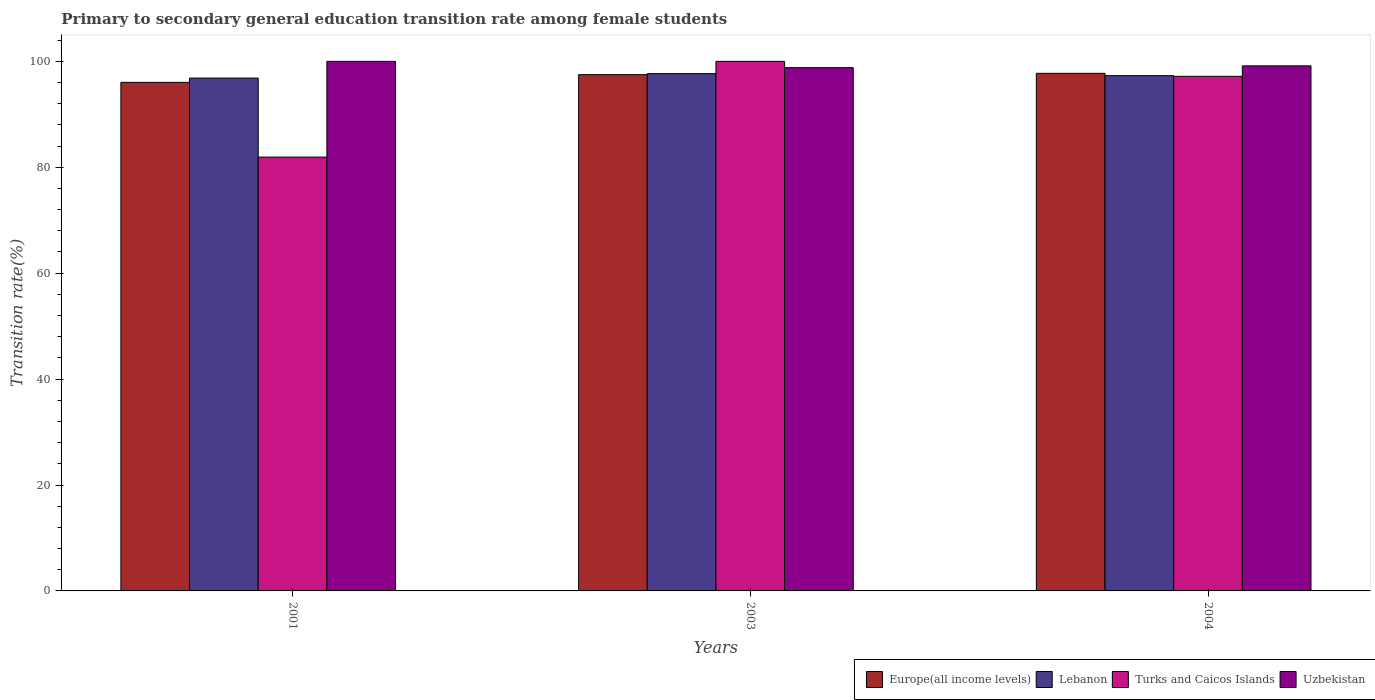How many groups of bars are there?
Ensure brevity in your answer.  3. Are the number of bars per tick equal to the number of legend labels?
Ensure brevity in your answer.  Yes. What is the transition rate in Europe(all income levels) in 2003?
Your answer should be compact. 97.49. Across all years, what is the maximum transition rate in Lebanon?
Provide a succinct answer. 97.69. Across all years, what is the minimum transition rate in Lebanon?
Ensure brevity in your answer.  96.84. In which year was the transition rate in Turks and Caicos Islands minimum?
Make the answer very short. 2001. What is the total transition rate in Europe(all income levels) in the graph?
Your response must be concise. 291.26. What is the difference between the transition rate in Turks and Caicos Islands in 2001 and that in 2004?
Provide a short and direct response. -15.25. What is the difference between the transition rate in Lebanon in 2003 and the transition rate in Europe(all income levels) in 2001?
Ensure brevity in your answer.  1.65. What is the average transition rate in Turks and Caicos Islands per year?
Your answer should be very brief. 93.03. In the year 2003, what is the difference between the transition rate in Uzbekistan and transition rate in Turks and Caicos Islands?
Offer a terse response. -1.19. In how many years, is the transition rate in Uzbekistan greater than 100 %?
Your response must be concise. 0. What is the ratio of the transition rate in Europe(all income levels) in 2001 to that in 2003?
Your answer should be compact. 0.99. Is the transition rate in Turks and Caicos Islands in 2001 less than that in 2003?
Keep it short and to the point. Yes. Is the difference between the transition rate in Uzbekistan in 2003 and 2004 greater than the difference between the transition rate in Turks and Caicos Islands in 2003 and 2004?
Your response must be concise. No. What is the difference between the highest and the second highest transition rate in Europe(all income levels)?
Offer a terse response. 0.25. What is the difference between the highest and the lowest transition rate in Europe(all income levels)?
Ensure brevity in your answer.  1.7. In how many years, is the transition rate in Turks and Caicos Islands greater than the average transition rate in Turks and Caicos Islands taken over all years?
Provide a short and direct response. 2. Is it the case that in every year, the sum of the transition rate in Uzbekistan and transition rate in Europe(all income levels) is greater than the sum of transition rate in Turks and Caicos Islands and transition rate in Lebanon?
Offer a terse response. No. What does the 1st bar from the left in 2003 represents?
Offer a terse response. Europe(all income levels). What does the 4th bar from the right in 2003 represents?
Offer a very short reply. Europe(all income levels). How many years are there in the graph?
Offer a very short reply. 3. What is the difference between two consecutive major ticks on the Y-axis?
Your answer should be compact. 20. Are the values on the major ticks of Y-axis written in scientific E-notation?
Make the answer very short. No. Where does the legend appear in the graph?
Give a very brief answer. Bottom right. How many legend labels are there?
Your answer should be compact. 4. What is the title of the graph?
Your answer should be compact. Primary to secondary general education transition rate among female students. What is the label or title of the X-axis?
Make the answer very short. Years. What is the label or title of the Y-axis?
Your answer should be compact. Transition rate(%). What is the Transition rate(%) in Europe(all income levels) in 2001?
Give a very brief answer. 96.03. What is the Transition rate(%) of Lebanon in 2001?
Offer a very short reply. 96.84. What is the Transition rate(%) of Turks and Caicos Islands in 2001?
Provide a succinct answer. 81.92. What is the Transition rate(%) in Uzbekistan in 2001?
Provide a short and direct response. 100. What is the Transition rate(%) in Europe(all income levels) in 2003?
Provide a succinct answer. 97.49. What is the Transition rate(%) in Lebanon in 2003?
Make the answer very short. 97.69. What is the Transition rate(%) in Uzbekistan in 2003?
Provide a succinct answer. 98.81. What is the Transition rate(%) in Europe(all income levels) in 2004?
Keep it short and to the point. 97.74. What is the Transition rate(%) of Lebanon in 2004?
Provide a succinct answer. 97.3. What is the Transition rate(%) in Turks and Caicos Islands in 2004?
Ensure brevity in your answer.  97.18. What is the Transition rate(%) in Uzbekistan in 2004?
Ensure brevity in your answer.  99.15. Across all years, what is the maximum Transition rate(%) of Europe(all income levels)?
Offer a terse response. 97.74. Across all years, what is the maximum Transition rate(%) in Lebanon?
Offer a terse response. 97.69. Across all years, what is the maximum Transition rate(%) of Turks and Caicos Islands?
Give a very brief answer. 100. Across all years, what is the minimum Transition rate(%) in Europe(all income levels)?
Offer a very short reply. 96.03. Across all years, what is the minimum Transition rate(%) of Lebanon?
Your response must be concise. 96.84. Across all years, what is the minimum Transition rate(%) in Turks and Caicos Islands?
Your answer should be compact. 81.92. Across all years, what is the minimum Transition rate(%) of Uzbekistan?
Your answer should be very brief. 98.81. What is the total Transition rate(%) of Europe(all income levels) in the graph?
Give a very brief answer. 291.26. What is the total Transition rate(%) of Lebanon in the graph?
Provide a short and direct response. 291.83. What is the total Transition rate(%) in Turks and Caicos Islands in the graph?
Your answer should be compact. 279.1. What is the total Transition rate(%) in Uzbekistan in the graph?
Offer a terse response. 297.96. What is the difference between the Transition rate(%) of Europe(all income levels) in 2001 and that in 2003?
Your answer should be very brief. -1.45. What is the difference between the Transition rate(%) of Lebanon in 2001 and that in 2003?
Offer a very short reply. -0.84. What is the difference between the Transition rate(%) of Turks and Caicos Islands in 2001 and that in 2003?
Give a very brief answer. -18.08. What is the difference between the Transition rate(%) of Uzbekistan in 2001 and that in 2003?
Your answer should be compact. 1.19. What is the difference between the Transition rate(%) in Europe(all income levels) in 2001 and that in 2004?
Offer a very short reply. -1.7. What is the difference between the Transition rate(%) in Lebanon in 2001 and that in 2004?
Give a very brief answer. -0.46. What is the difference between the Transition rate(%) in Turks and Caicos Islands in 2001 and that in 2004?
Give a very brief answer. -15.25. What is the difference between the Transition rate(%) of Uzbekistan in 2001 and that in 2004?
Offer a very short reply. 0.85. What is the difference between the Transition rate(%) of Europe(all income levels) in 2003 and that in 2004?
Provide a short and direct response. -0.25. What is the difference between the Transition rate(%) of Lebanon in 2003 and that in 2004?
Offer a very short reply. 0.39. What is the difference between the Transition rate(%) of Turks and Caicos Islands in 2003 and that in 2004?
Your answer should be compact. 2.82. What is the difference between the Transition rate(%) in Uzbekistan in 2003 and that in 2004?
Ensure brevity in your answer.  -0.34. What is the difference between the Transition rate(%) in Europe(all income levels) in 2001 and the Transition rate(%) in Lebanon in 2003?
Make the answer very short. -1.65. What is the difference between the Transition rate(%) in Europe(all income levels) in 2001 and the Transition rate(%) in Turks and Caicos Islands in 2003?
Your response must be concise. -3.97. What is the difference between the Transition rate(%) of Europe(all income levels) in 2001 and the Transition rate(%) of Uzbekistan in 2003?
Offer a terse response. -2.77. What is the difference between the Transition rate(%) in Lebanon in 2001 and the Transition rate(%) in Turks and Caicos Islands in 2003?
Provide a succinct answer. -3.16. What is the difference between the Transition rate(%) in Lebanon in 2001 and the Transition rate(%) in Uzbekistan in 2003?
Offer a very short reply. -1.96. What is the difference between the Transition rate(%) of Turks and Caicos Islands in 2001 and the Transition rate(%) of Uzbekistan in 2003?
Provide a succinct answer. -16.89. What is the difference between the Transition rate(%) in Europe(all income levels) in 2001 and the Transition rate(%) in Lebanon in 2004?
Your answer should be compact. -1.27. What is the difference between the Transition rate(%) in Europe(all income levels) in 2001 and the Transition rate(%) in Turks and Caicos Islands in 2004?
Provide a succinct answer. -1.14. What is the difference between the Transition rate(%) of Europe(all income levels) in 2001 and the Transition rate(%) of Uzbekistan in 2004?
Your answer should be very brief. -3.12. What is the difference between the Transition rate(%) of Lebanon in 2001 and the Transition rate(%) of Turks and Caicos Islands in 2004?
Your answer should be very brief. -0.33. What is the difference between the Transition rate(%) in Lebanon in 2001 and the Transition rate(%) in Uzbekistan in 2004?
Keep it short and to the point. -2.31. What is the difference between the Transition rate(%) of Turks and Caicos Islands in 2001 and the Transition rate(%) of Uzbekistan in 2004?
Make the answer very short. -17.23. What is the difference between the Transition rate(%) of Europe(all income levels) in 2003 and the Transition rate(%) of Lebanon in 2004?
Your response must be concise. 0.18. What is the difference between the Transition rate(%) of Europe(all income levels) in 2003 and the Transition rate(%) of Turks and Caicos Islands in 2004?
Give a very brief answer. 0.31. What is the difference between the Transition rate(%) of Europe(all income levels) in 2003 and the Transition rate(%) of Uzbekistan in 2004?
Make the answer very short. -1.67. What is the difference between the Transition rate(%) of Lebanon in 2003 and the Transition rate(%) of Turks and Caicos Islands in 2004?
Keep it short and to the point. 0.51. What is the difference between the Transition rate(%) in Lebanon in 2003 and the Transition rate(%) in Uzbekistan in 2004?
Your response must be concise. -1.46. What is the difference between the Transition rate(%) in Turks and Caicos Islands in 2003 and the Transition rate(%) in Uzbekistan in 2004?
Provide a succinct answer. 0.85. What is the average Transition rate(%) of Europe(all income levels) per year?
Your answer should be very brief. 97.09. What is the average Transition rate(%) of Lebanon per year?
Keep it short and to the point. 97.28. What is the average Transition rate(%) of Turks and Caicos Islands per year?
Make the answer very short. 93.03. What is the average Transition rate(%) in Uzbekistan per year?
Offer a very short reply. 99.32. In the year 2001, what is the difference between the Transition rate(%) in Europe(all income levels) and Transition rate(%) in Lebanon?
Offer a terse response. -0.81. In the year 2001, what is the difference between the Transition rate(%) in Europe(all income levels) and Transition rate(%) in Turks and Caicos Islands?
Make the answer very short. 14.11. In the year 2001, what is the difference between the Transition rate(%) of Europe(all income levels) and Transition rate(%) of Uzbekistan?
Your response must be concise. -3.97. In the year 2001, what is the difference between the Transition rate(%) in Lebanon and Transition rate(%) in Turks and Caicos Islands?
Offer a very short reply. 14.92. In the year 2001, what is the difference between the Transition rate(%) in Lebanon and Transition rate(%) in Uzbekistan?
Give a very brief answer. -3.16. In the year 2001, what is the difference between the Transition rate(%) of Turks and Caicos Islands and Transition rate(%) of Uzbekistan?
Keep it short and to the point. -18.08. In the year 2003, what is the difference between the Transition rate(%) in Europe(all income levels) and Transition rate(%) in Lebanon?
Ensure brevity in your answer.  -0.2. In the year 2003, what is the difference between the Transition rate(%) in Europe(all income levels) and Transition rate(%) in Turks and Caicos Islands?
Provide a succinct answer. -2.51. In the year 2003, what is the difference between the Transition rate(%) in Europe(all income levels) and Transition rate(%) in Uzbekistan?
Your answer should be compact. -1.32. In the year 2003, what is the difference between the Transition rate(%) of Lebanon and Transition rate(%) of Turks and Caicos Islands?
Ensure brevity in your answer.  -2.31. In the year 2003, what is the difference between the Transition rate(%) of Lebanon and Transition rate(%) of Uzbekistan?
Your response must be concise. -1.12. In the year 2003, what is the difference between the Transition rate(%) in Turks and Caicos Islands and Transition rate(%) in Uzbekistan?
Give a very brief answer. 1.19. In the year 2004, what is the difference between the Transition rate(%) of Europe(all income levels) and Transition rate(%) of Lebanon?
Keep it short and to the point. 0.44. In the year 2004, what is the difference between the Transition rate(%) of Europe(all income levels) and Transition rate(%) of Turks and Caicos Islands?
Your answer should be compact. 0.56. In the year 2004, what is the difference between the Transition rate(%) in Europe(all income levels) and Transition rate(%) in Uzbekistan?
Keep it short and to the point. -1.41. In the year 2004, what is the difference between the Transition rate(%) in Lebanon and Transition rate(%) in Turks and Caicos Islands?
Offer a terse response. 0.13. In the year 2004, what is the difference between the Transition rate(%) in Lebanon and Transition rate(%) in Uzbekistan?
Your answer should be very brief. -1.85. In the year 2004, what is the difference between the Transition rate(%) in Turks and Caicos Islands and Transition rate(%) in Uzbekistan?
Your answer should be very brief. -1.98. What is the ratio of the Transition rate(%) of Europe(all income levels) in 2001 to that in 2003?
Make the answer very short. 0.99. What is the ratio of the Transition rate(%) in Lebanon in 2001 to that in 2003?
Your response must be concise. 0.99. What is the ratio of the Transition rate(%) of Turks and Caicos Islands in 2001 to that in 2003?
Make the answer very short. 0.82. What is the ratio of the Transition rate(%) in Uzbekistan in 2001 to that in 2003?
Give a very brief answer. 1.01. What is the ratio of the Transition rate(%) in Europe(all income levels) in 2001 to that in 2004?
Your response must be concise. 0.98. What is the ratio of the Transition rate(%) in Lebanon in 2001 to that in 2004?
Offer a terse response. 1. What is the ratio of the Transition rate(%) of Turks and Caicos Islands in 2001 to that in 2004?
Keep it short and to the point. 0.84. What is the ratio of the Transition rate(%) in Uzbekistan in 2001 to that in 2004?
Offer a very short reply. 1.01. What is the ratio of the Transition rate(%) of Europe(all income levels) in 2003 to that in 2004?
Your answer should be very brief. 1. What is the ratio of the Transition rate(%) of Turks and Caicos Islands in 2003 to that in 2004?
Provide a short and direct response. 1.03. What is the difference between the highest and the second highest Transition rate(%) of Europe(all income levels)?
Your answer should be very brief. 0.25. What is the difference between the highest and the second highest Transition rate(%) of Lebanon?
Ensure brevity in your answer.  0.39. What is the difference between the highest and the second highest Transition rate(%) of Turks and Caicos Islands?
Provide a succinct answer. 2.82. What is the difference between the highest and the second highest Transition rate(%) in Uzbekistan?
Ensure brevity in your answer.  0.85. What is the difference between the highest and the lowest Transition rate(%) of Europe(all income levels)?
Provide a succinct answer. 1.7. What is the difference between the highest and the lowest Transition rate(%) in Lebanon?
Provide a succinct answer. 0.84. What is the difference between the highest and the lowest Transition rate(%) of Turks and Caicos Islands?
Give a very brief answer. 18.08. What is the difference between the highest and the lowest Transition rate(%) in Uzbekistan?
Your answer should be very brief. 1.19. 